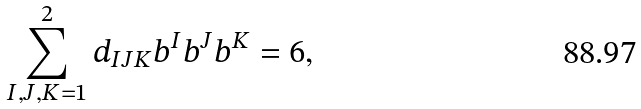<formula> <loc_0><loc_0><loc_500><loc_500>\sum _ { I , J , K = 1 } ^ { 2 } d _ { I J K } b ^ { I } b ^ { J } b ^ { K } = 6 ,</formula> 